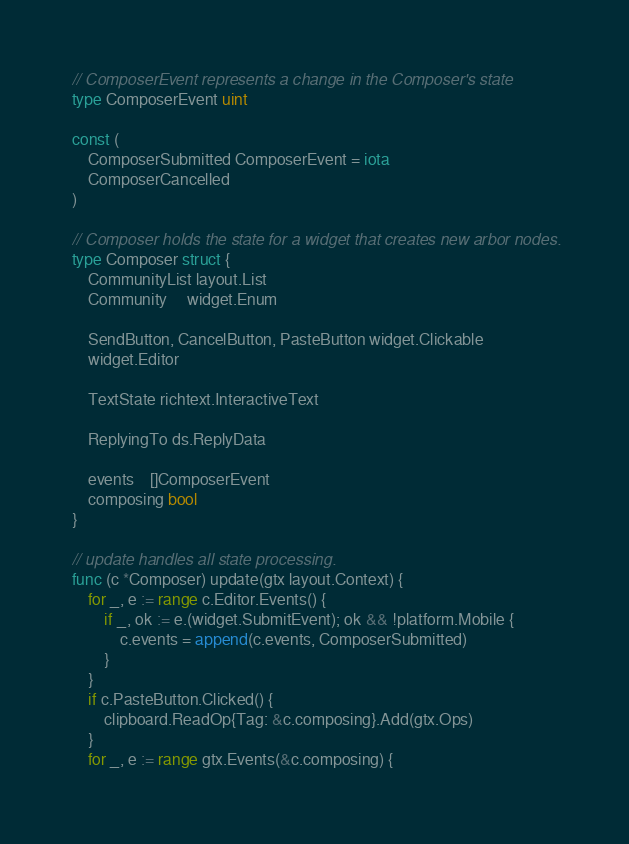Convert code to text. <code><loc_0><loc_0><loc_500><loc_500><_Go_>// ComposerEvent represents a change in the Composer's state
type ComposerEvent uint

const (
	ComposerSubmitted ComposerEvent = iota
	ComposerCancelled
)

// Composer holds the state for a widget that creates new arbor nodes.
type Composer struct {
	CommunityList layout.List
	Community     widget.Enum

	SendButton, CancelButton, PasteButton widget.Clickable
	widget.Editor

	TextState richtext.InteractiveText

	ReplyingTo ds.ReplyData

	events    []ComposerEvent
	composing bool
}

// update handles all state processing.
func (c *Composer) update(gtx layout.Context) {
	for _, e := range c.Editor.Events() {
		if _, ok := e.(widget.SubmitEvent); ok && !platform.Mobile {
			c.events = append(c.events, ComposerSubmitted)
		}
	}
	if c.PasteButton.Clicked() {
		clipboard.ReadOp{Tag: &c.composing}.Add(gtx.Ops)
	}
	for _, e := range gtx.Events(&c.composing) {</code> 